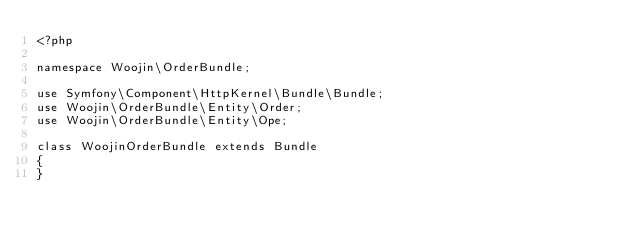<code> <loc_0><loc_0><loc_500><loc_500><_PHP_><?php

namespace Woojin\OrderBundle;

use Symfony\Component\HttpKernel\Bundle\Bundle;
use Woojin\OrderBundle\Entity\Order;
use Woojin\OrderBundle\Entity\Ope;

class WoojinOrderBundle extends Bundle
{
}
</code> 